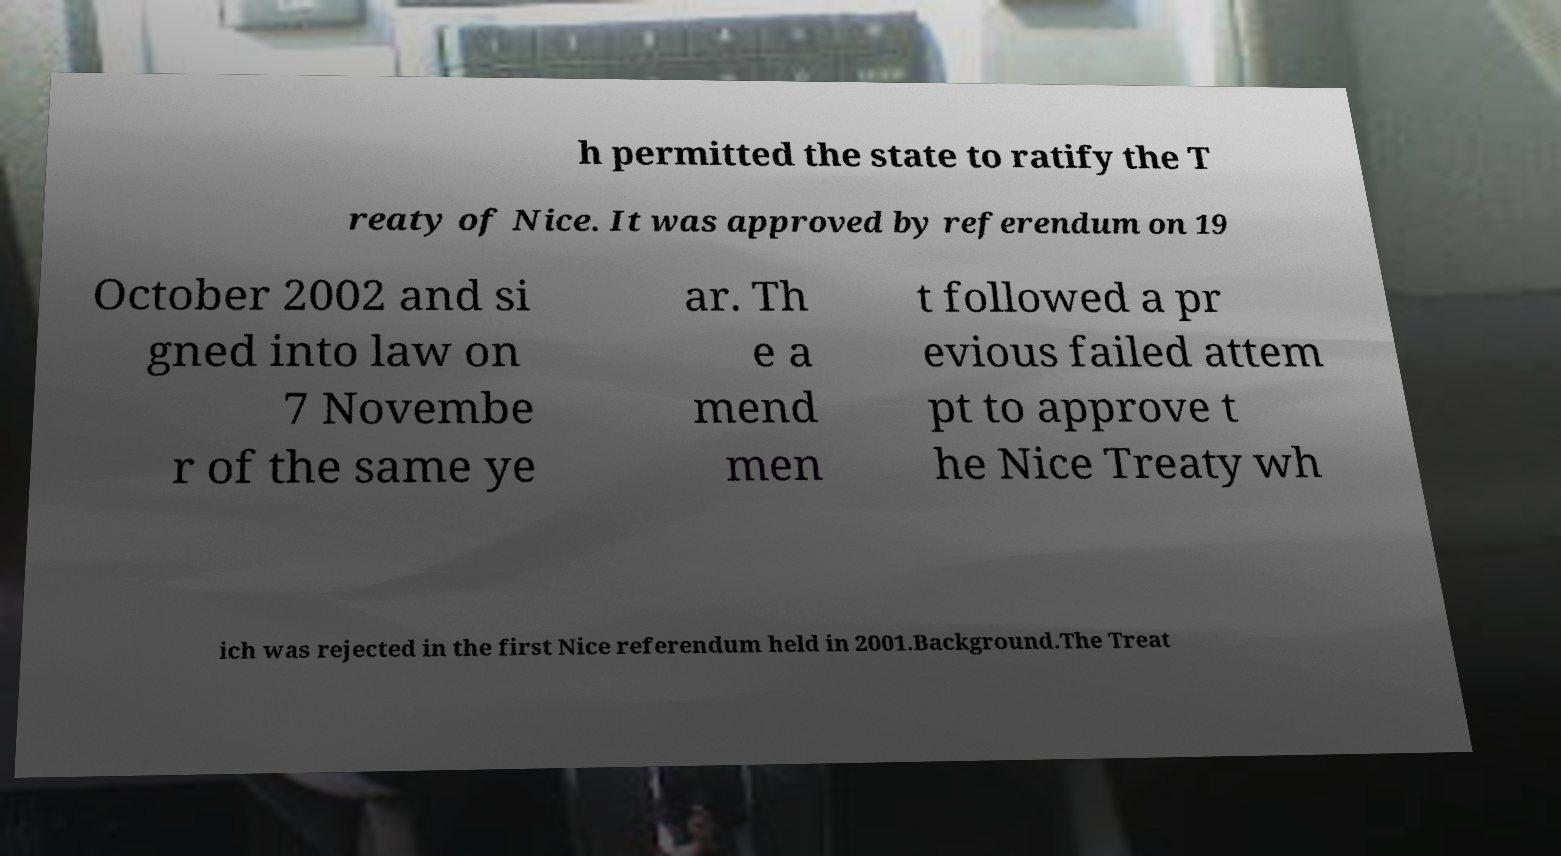There's text embedded in this image that I need extracted. Can you transcribe it verbatim? h permitted the state to ratify the T reaty of Nice. It was approved by referendum on 19 October 2002 and si gned into law on 7 Novembe r of the same ye ar. Th e a mend men t followed a pr evious failed attem pt to approve t he Nice Treaty wh ich was rejected in the first Nice referendum held in 2001.Background.The Treat 